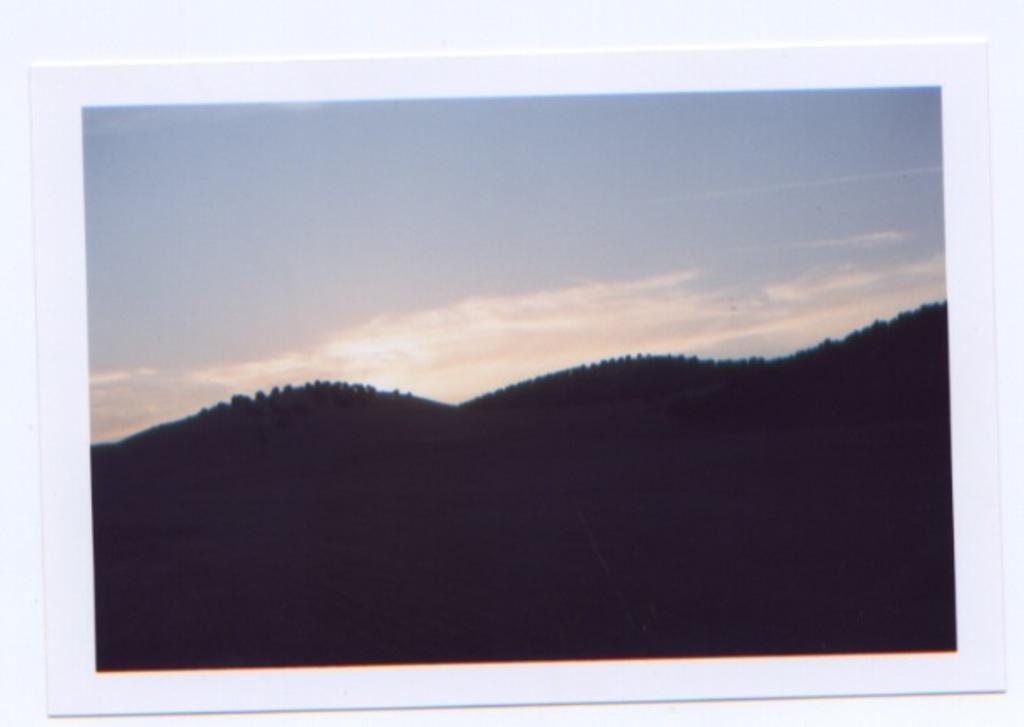What type of vegetation can be seen on the mountains in the image? There are trees on the mountains in the image. What is visible at the top of the image? The sky is visible at the top of the image. What can be seen in the sky in the image? There are clouds in the sky. Can you tell me how many times the calendar is mentioned in the image? There is no mention of a calendar in the image. What type of snow can be seen on the trees in the image? There is no snow present in the image; it features trees on mountains with visible clouds in the sky. 